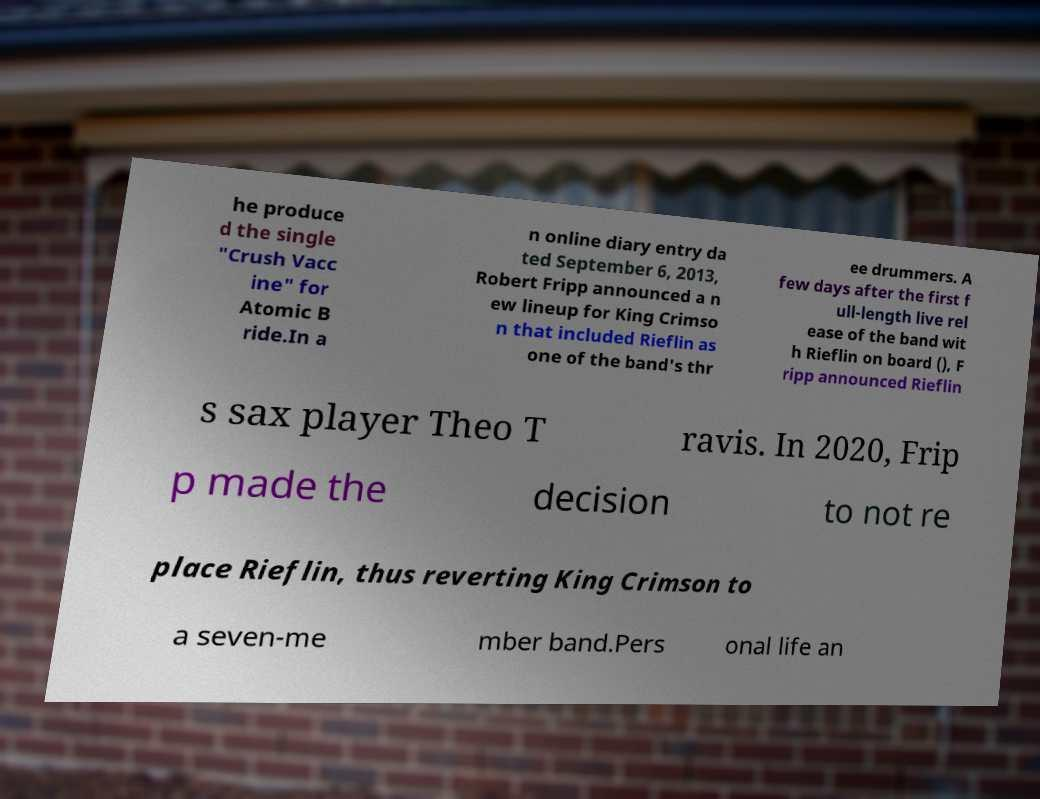Could you extract and type out the text from this image? he produce d the single "Crush Vacc ine" for Atomic B ride.In a n online diary entry da ted September 6, 2013, Robert Fripp announced a n ew lineup for King Crimso n that included Rieflin as one of the band's thr ee drummers. A few days after the first f ull-length live rel ease of the band wit h Rieflin on board (), F ripp announced Rieflin s sax player Theo T ravis. In 2020, Frip p made the decision to not re place Rieflin, thus reverting King Crimson to a seven-me mber band.Pers onal life an 